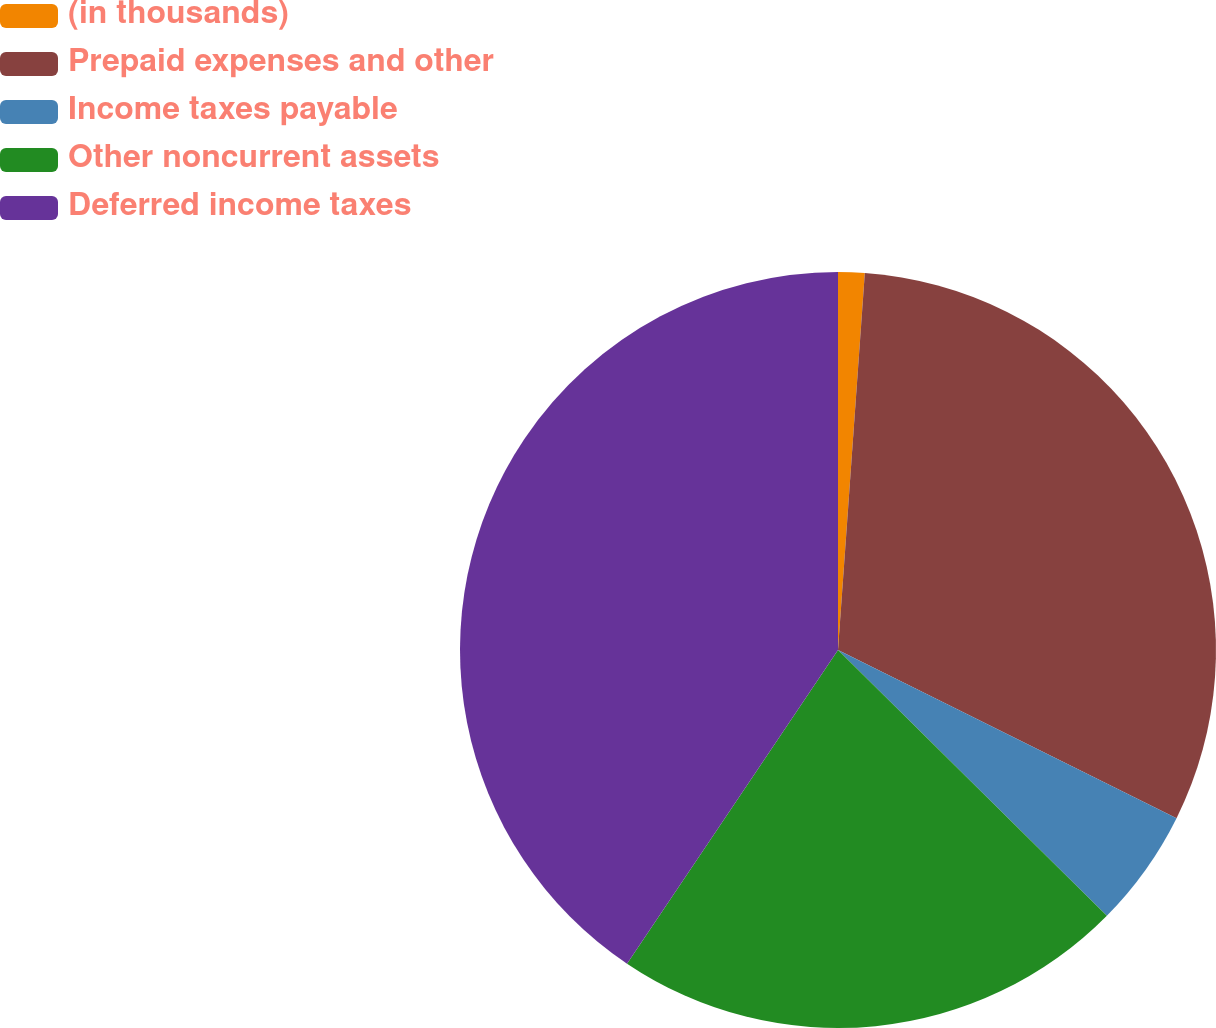<chart> <loc_0><loc_0><loc_500><loc_500><pie_chart><fcel>(in thousands)<fcel>Prepaid expenses and other<fcel>Income taxes payable<fcel>Other noncurrent assets<fcel>Deferred income taxes<nl><fcel>1.13%<fcel>31.21%<fcel>5.07%<fcel>22.02%<fcel>40.58%<nl></chart> 